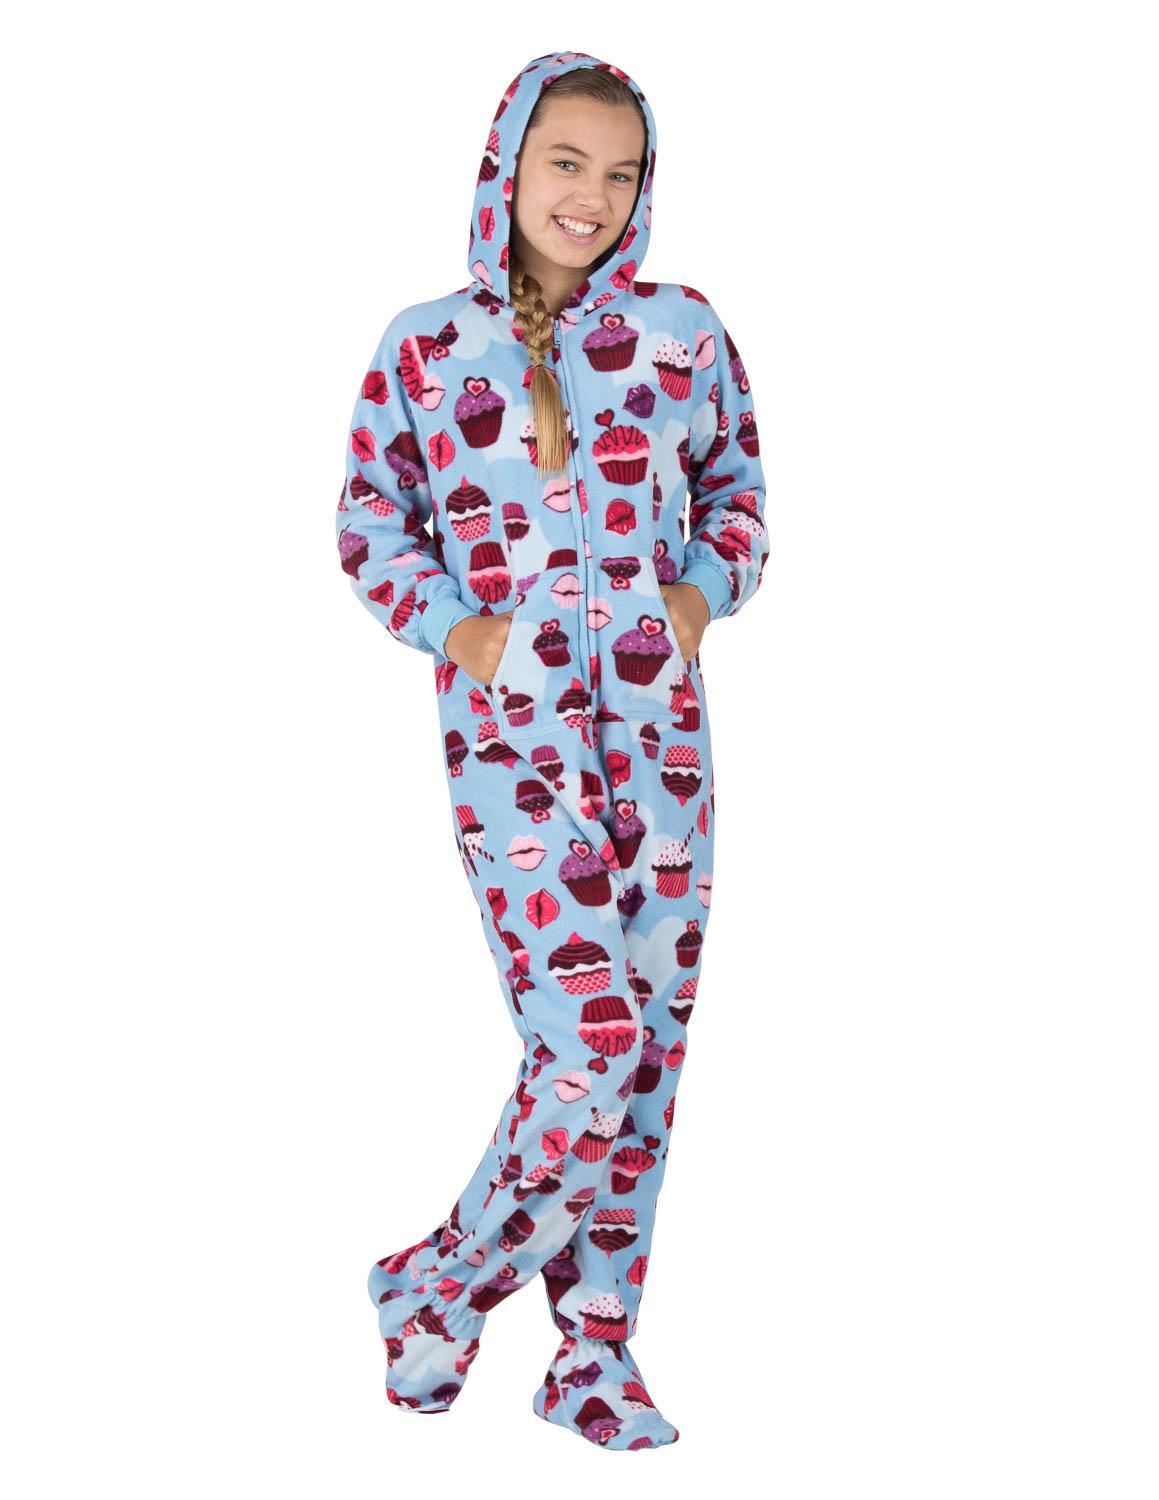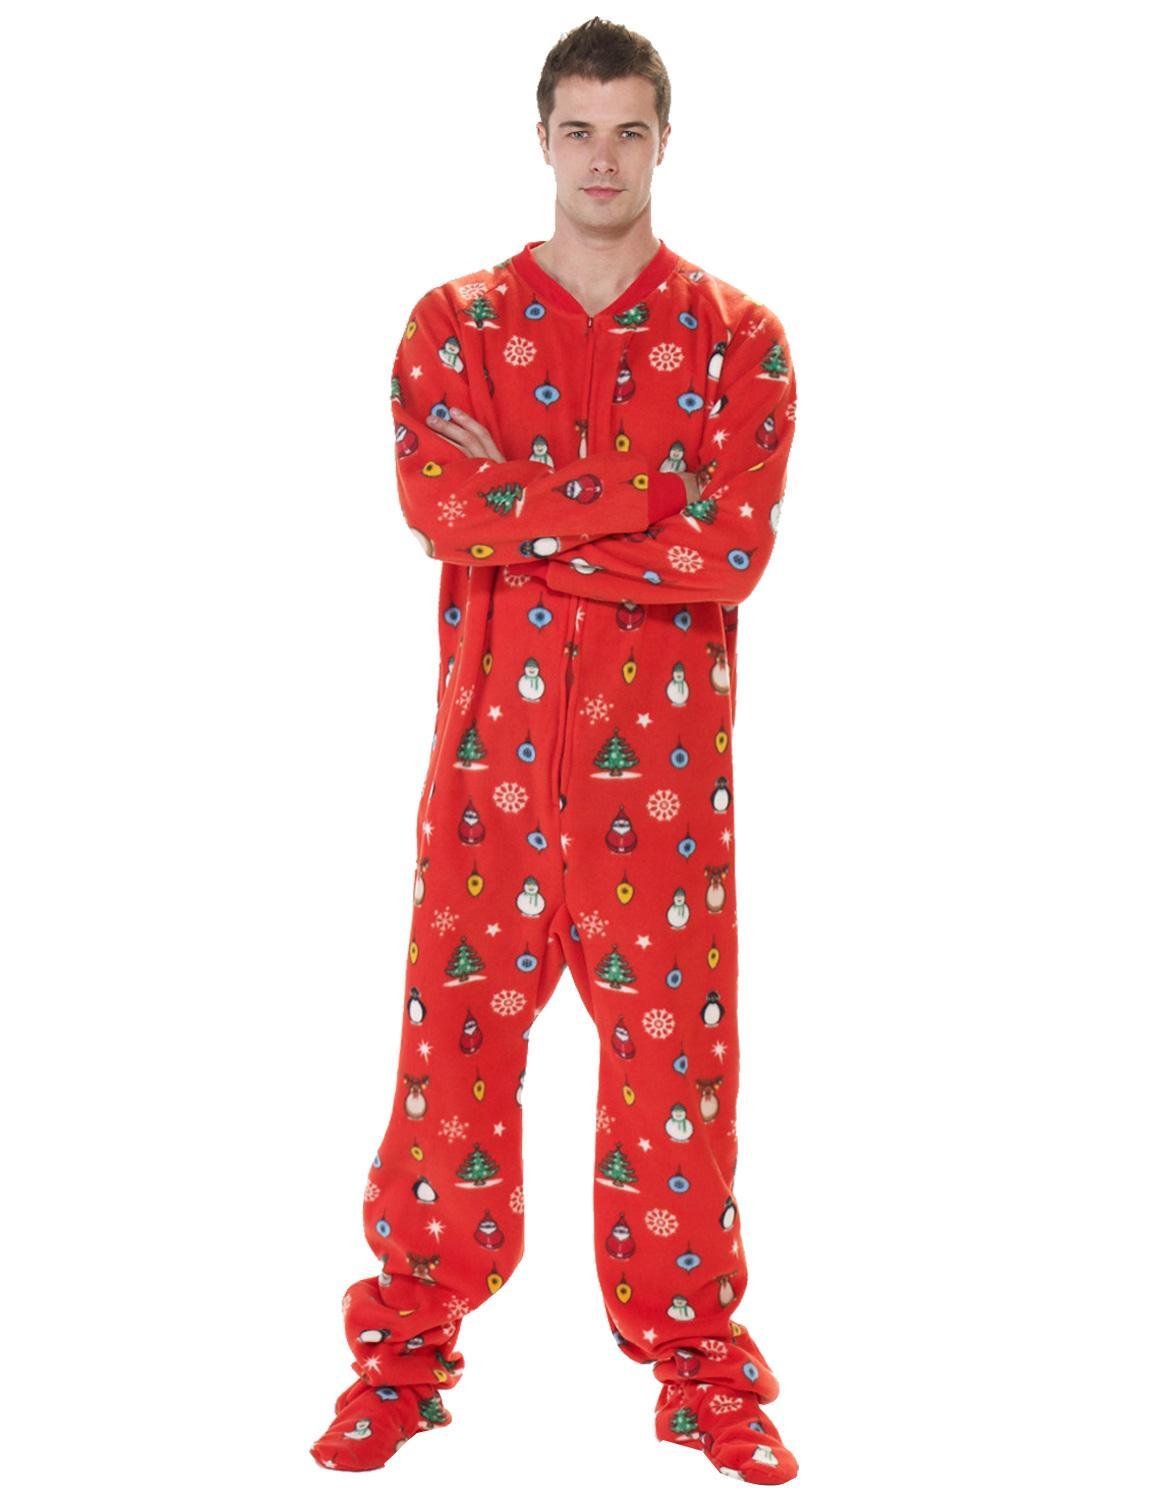The first image is the image on the left, the second image is the image on the right. Analyze the images presented: Is the assertion "There are two female wearing pajamas by themselves" valid? Answer yes or no. No. The first image is the image on the left, the second image is the image on the right. Assess this claim about the two images: "There is at least one person with their hood up.". Correct or not? Answer yes or no. Yes. 